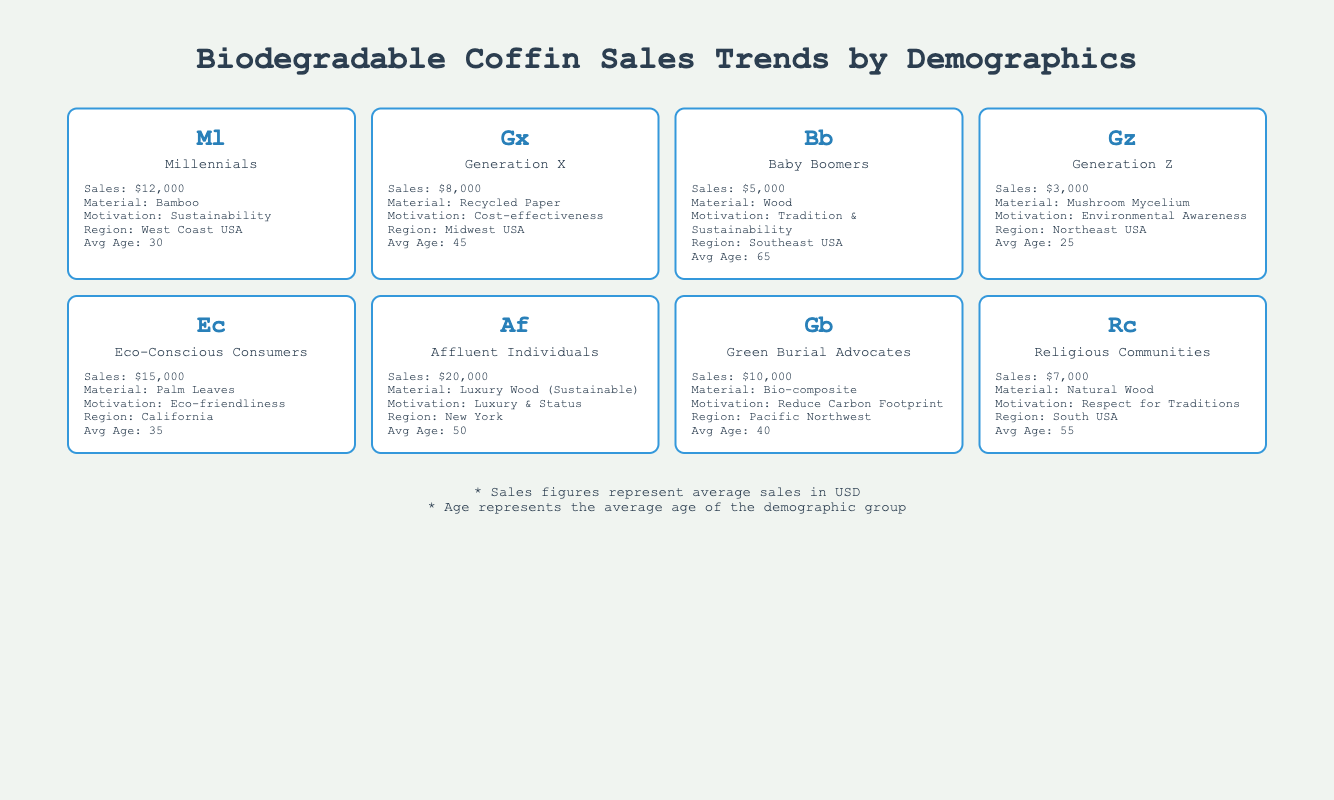what is the preferred material for Eco-Conscious Consumers? Eco-Conscious Consumers prefer Palm Leaves as their material choice for biodegradable coffins, as indicated under the "preferred material" category for that demographic group in the table.
Answer: Palm Leaves which demographic group has the highest average sales? The demographic group with the highest average sales is Affluent Individuals, with average sales of $20,000, as shown in the sales figures for each group in the table.
Answer: Affluent Individuals how many demographics have an average sales figure above 10,000? The demographics with average sales above 10,000 are Eco-Conscious Consumers (15,000) and Affluent Individuals (20,000). Therefore, there are 2 demographics meeting this criterion.
Answer: 2 are Baby Boomers more likely to prefer Natural Wood than Millennials? Baby Boomers do prefer Natural Wood, but Millennials prefer Bamboo. Since Millennials do not prefer Natural Wood, the statement is false.
Answer: No what is the average age of the Green Burial Advocates? The average age of the Green Burial Advocates is 40 years, as stated in the age category for this demographic group in the table.
Answer: 40 which demographic has the highest percentage of female customers? The Eco-Conscious Consumers have the highest percentage of female customers at 70%, as seen in the gender distribution for that group.
Answer: Eco-Conscious Consumers if you sum up the average sales of all demographic groups, what is the total? Adding up the average sales figures for all demographic groups: 12000 + 8000 + 5000 + 3000 + 15000 + 20000 + 10000 + 7000 = 60000, so the total is 60000.
Answer: 60000 what is the primary motivation for the Generation Z group? Generation Z's primary motivation for purchasing biodegradable coffins is Environmental Awareness, as listed for that demographic in the table.
Answer: Environmental Awareness how do average sales of Baby Boomers compare to the average sales of Millennials? Baby Boomers have average sales of $5,000, while Millennials have average sales of $12,000. Thus, Millennials have higher average sales than Baby Boomers by a difference of $7,000.
Answer: Millennials have higher average sales by 7000 